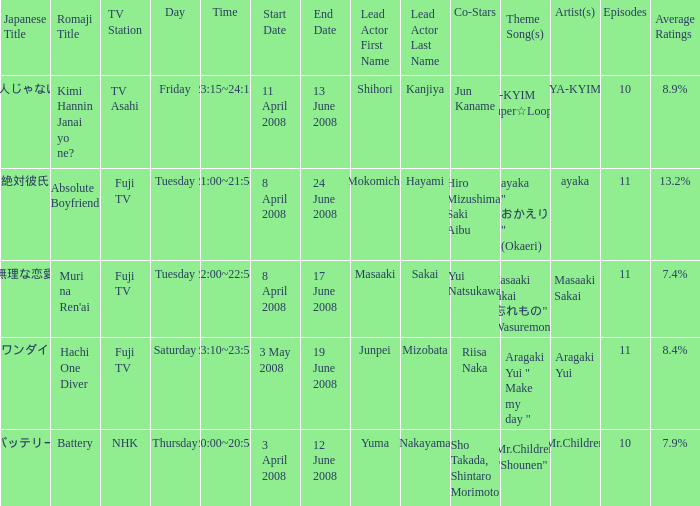How many titles had an average rating of 8.9%? 1.0. 